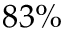Convert formula to latex. <formula><loc_0><loc_0><loc_500><loc_500>8 3 \%</formula> 